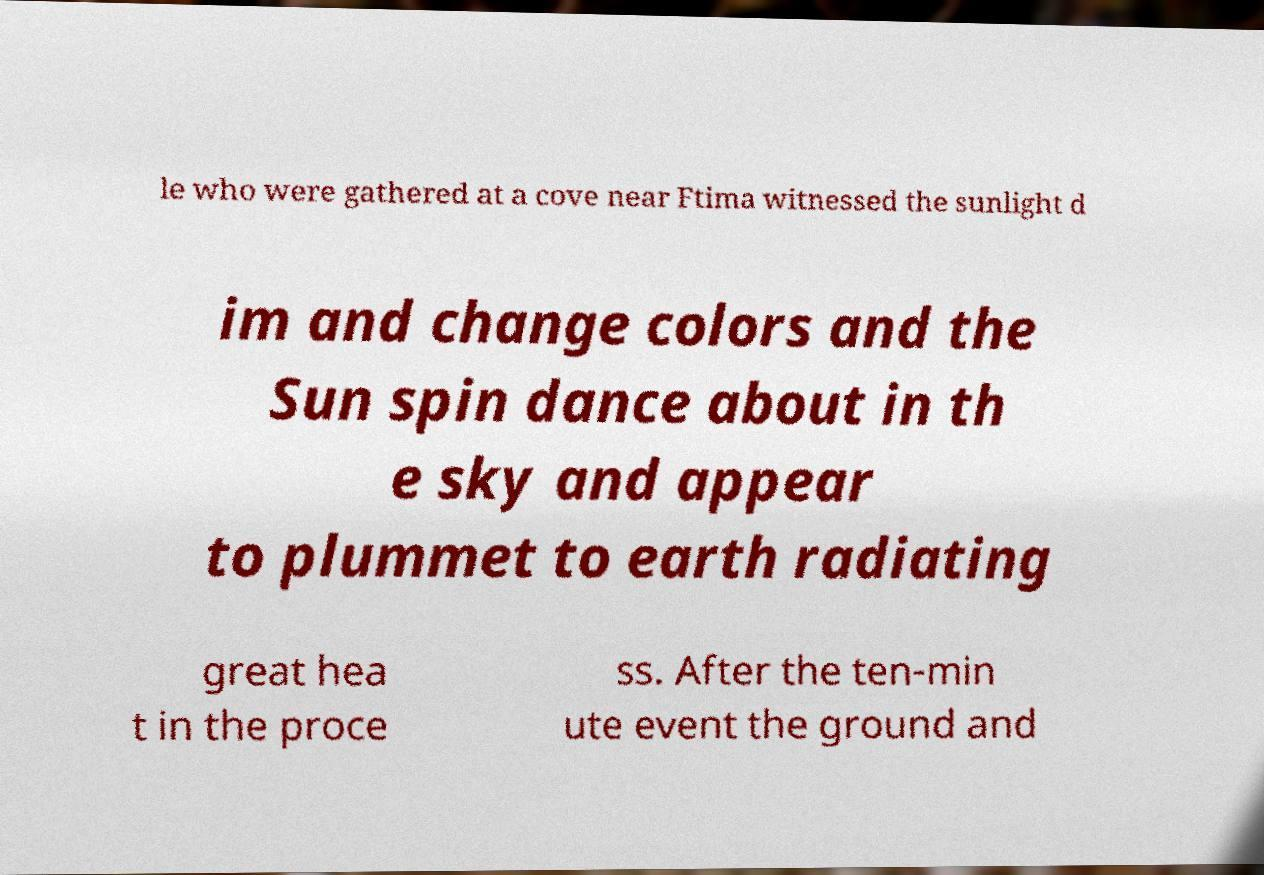Please read and relay the text visible in this image. What does it say? le who were gathered at a cove near Ftima witnessed the sunlight d im and change colors and the Sun spin dance about in th e sky and appear to plummet to earth radiating great hea t in the proce ss. After the ten-min ute event the ground and 